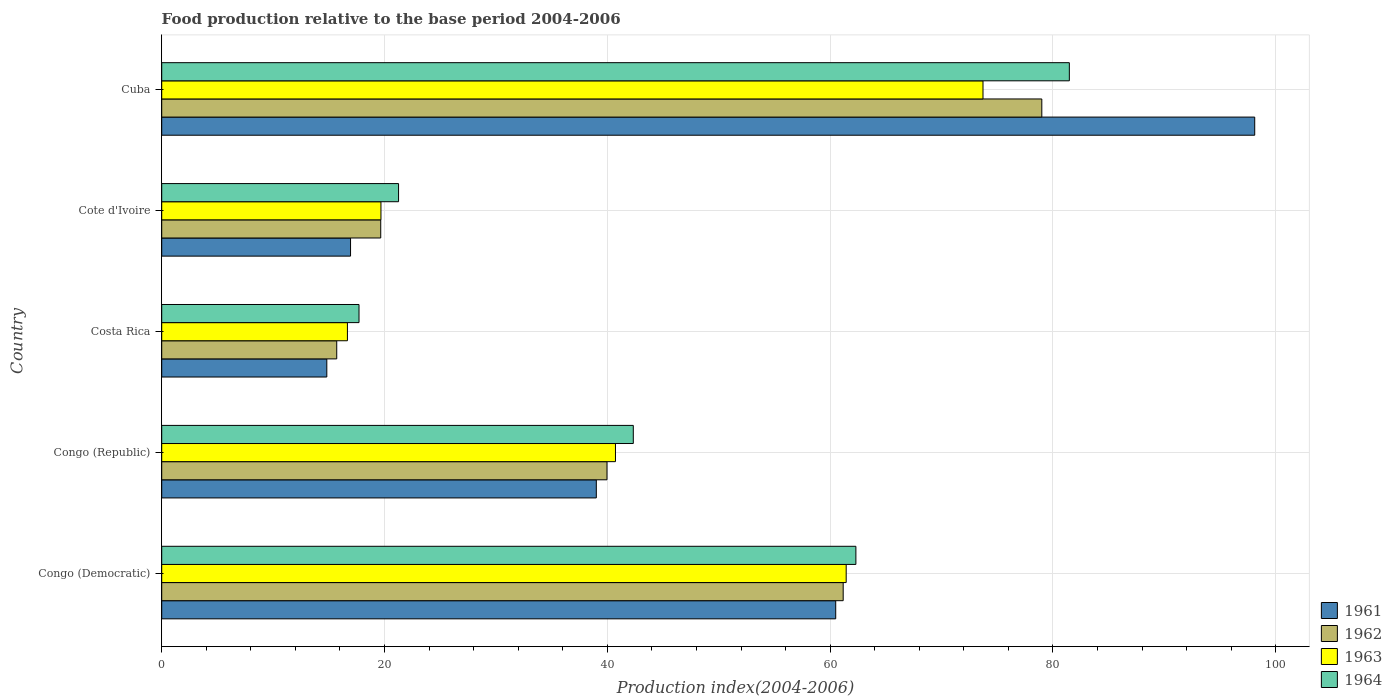How many different coloured bars are there?
Your answer should be compact. 4. Are the number of bars per tick equal to the number of legend labels?
Your answer should be compact. Yes. What is the label of the 2nd group of bars from the top?
Offer a very short reply. Cote d'Ivoire. What is the food production index in 1961 in Cuba?
Your answer should be very brief. 98.11. Across all countries, what is the maximum food production index in 1962?
Give a very brief answer. 79. Across all countries, what is the minimum food production index in 1962?
Offer a terse response. 15.71. In which country was the food production index in 1964 maximum?
Your answer should be very brief. Cuba. What is the total food production index in 1964 in the graph?
Your response must be concise. 225.08. What is the difference between the food production index in 1962 in Costa Rica and that in Cote d'Ivoire?
Offer a terse response. -3.95. What is the difference between the food production index in 1961 in Congo (Democratic) and the food production index in 1962 in Cuba?
Your answer should be very brief. -18.5. What is the average food production index in 1963 per country?
Offer a terse response. 42.45. What is the difference between the food production index in 1964 and food production index in 1961 in Cuba?
Give a very brief answer. -16.64. What is the ratio of the food production index in 1963 in Congo (Democratic) to that in Cuba?
Provide a short and direct response. 0.83. Is the food production index in 1962 in Congo (Democratic) less than that in Costa Rica?
Your answer should be very brief. No. What is the difference between the highest and the second highest food production index in 1961?
Offer a terse response. 37.61. What is the difference between the highest and the lowest food production index in 1962?
Provide a succinct answer. 63.29. In how many countries, is the food production index in 1962 greater than the average food production index in 1962 taken over all countries?
Offer a very short reply. 2. What does the 4th bar from the bottom in Costa Rica represents?
Your answer should be very brief. 1964. How many bars are there?
Your answer should be very brief. 20. How many countries are there in the graph?
Ensure brevity in your answer.  5. Are the values on the major ticks of X-axis written in scientific E-notation?
Offer a very short reply. No. How many legend labels are there?
Your answer should be very brief. 4. What is the title of the graph?
Provide a short and direct response. Food production relative to the base period 2004-2006. What is the label or title of the X-axis?
Offer a terse response. Production index(2004-2006). What is the Production index(2004-2006) of 1961 in Congo (Democratic)?
Provide a succinct answer. 60.5. What is the Production index(2004-2006) in 1962 in Congo (Democratic)?
Your response must be concise. 61.17. What is the Production index(2004-2006) in 1963 in Congo (Democratic)?
Your response must be concise. 61.44. What is the Production index(2004-2006) of 1964 in Congo (Democratic)?
Offer a terse response. 62.31. What is the Production index(2004-2006) of 1961 in Congo (Republic)?
Make the answer very short. 39.01. What is the Production index(2004-2006) of 1962 in Congo (Republic)?
Ensure brevity in your answer.  39.97. What is the Production index(2004-2006) in 1963 in Congo (Republic)?
Make the answer very short. 40.73. What is the Production index(2004-2006) of 1964 in Congo (Republic)?
Offer a terse response. 42.33. What is the Production index(2004-2006) in 1961 in Costa Rica?
Make the answer very short. 14.82. What is the Production index(2004-2006) of 1962 in Costa Rica?
Offer a terse response. 15.71. What is the Production index(2004-2006) in 1963 in Costa Rica?
Your answer should be very brief. 16.67. What is the Production index(2004-2006) in 1964 in Costa Rica?
Your answer should be compact. 17.71. What is the Production index(2004-2006) of 1961 in Cote d'Ivoire?
Offer a terse response. 16.95. What is the Production index(2004-2006) in 1962 in Cote d'Ivoire?
Keep it short and to the point. 19.66. What is the Production index(2004-2006) in 1963 in Cote d'Ivoire?
Offer a terse response. 19.68. What is the Production index(2004-2006) of 1964 in Cote d'Ivoire?
Provide a succinct answer. 21.26. What is the Production index(2004-2006) of 1961 in Cuba?
Provide a succinct answer. 98.11. What is the Production index(2004-2006) of 1962 in Cuba?
Ensure brevity in your answer.  79. What is the Production index(2004-2006) in 1963 in Cuba?
Your answer should be very brief. 73.72. What is the Production index(2004-2006) of 1964 in Cuba?
Provide a succinct answer. 81.47. Across all countries, what is the maximum Production index(2004-2006) in 1961?
Offer a very short reply. 98.11. Across all countries, what is the maximum Production index(2004-2006) of 1962?
Provide a short and direct response. 79. Across all countries, what is the maximum Production index(2004-2006) in 1963?
Your answer should be compact. 73.72. Across all countries, what is the maximum Production index(2004-2006) in 1964?
Offer a terse response. 81.47. Across all countries, what is the minimum Production index(2004-2006) of 1961?
Offer a terse response. 14.82. Across all countries, what is the minimum Production index(2004-2006) of 1962?
Provide a succinct answer. 15.71. Across all countries, what is the minimum Production index(2004-2006) in 1963?
Offer a terse response. 16.67. Across all countries, what is the minimum Production index(2004-2006) of 1964?
Ensure brevity in your answer.  17.71. What is the total Production index(2004-2006) in 1961 in the graph?
Offer a very short reply. 229.39. What is the total Production index(2004-2006) of 1962 in the graph?
Give a very brief answer. 215.51. What is the total Production index(2004-2006) of 1963 in the graph?
Provide a succinct answer. 212.24. What is the total Production index(2004-2006) in 1964 in the graph?
Provide a short and direct response. 225.08. What is the difference between the Production index(2004-2006) in 1961 in Congo (Democratic) and that in Congo (Republic)?
Your answer should be compact. 21.49. What is the difference between the Production index(2004-2006) of 1962 in Congo (Democratic) and that in Congo (Republic)?
Offer a terse response. 21.2. What is the difference between the Production index(2004-2006) in 1963 in Congo (Democratic) and that in Congo (Republic)?
Ensure brevity in your answer.  20.71. What is the difference between the Production index(2004-2006) of 1964 in Congo (Democratic) and that in Congo (Republic)?
Offer a very short reply. 19.98. What is the difference between the Production index(2004-2006) of 1961 in Congo (Democratic) and that in Costa Rica?
Provide a succinct answer. 45.68. What is the difference between the Production index(2004-2006) in 1962 in Congo (Democratic) and that in Costa Rica?
Make the answer very short. 45.46. What is the difference between the Production index(2004-2006) in 1963 in Congo (Democratic) and that in Costa Rica?
Provide a short and direct response. 44.77. What is the difference between the Production index(2004-2006) of 1964 in Congo (Democratic) and that in Costa Rica?
Your answer should be compact. 44.6. What is the difference between the Production index(2004-2006) of 1961 in Congo (Democratic) and that in Cote d'Ivoire?
Give a very brief answer. 43.55. What is the difference between the Production index(2004-2006) in 1962 in Congo (Democratic) and that in Cote d'Ivoire?
Keep it short and to the point. 41.51. What is the difference between the Production index(2004-2006) of 1963 in Congo (Democratic) and that in Cote d'Ivoire?
Provide a succinct answer. 41.76. What is the difference between the Production index(2004-2006) in 1964 in Congo (Democratic) and that in Cote d'Ivoire?
Provide a succinct answer. 41.05. What is the difference between the Production index(2004-2006) in 1961 in Congo (Democratic) and that in Cuba?
Your response must be concise. -37.61. What is the difference between the Production index(2004-2006) of 1962 in Congo (Democratic) and that in Cuba?
Keep it short and to the point. -17.83. What is the difference between the Production index(2004-2006) of 1963 in Congo (Democratic) and that in Cuba?
Make the answer very short. -12.28. What is the difference between the Production index(2004-2006) in 1964 in Congo (Democratic) and that in Cuba?
Provide a succinct answer. -19.16. What is the difference between the Production index(2004-2006) in 1961 in Congo (Republic) and that in Costa Rica?
Your answer should be compact. 24.19. What is the difference between the Production index(2004-2006) of 1962 in Congo (Republic) and that in Costa Rica?
Your answer should be compact. 24.26. What is the difference between the Production index(2004-2006) in 1963 in Congo (Republic) and that in Costa Rica?
Your answer should be compact. 24.06. What is the difference between the Production index(2004-2006) in 1964 in Congo (Republic) and that in Costa Rica?
Ensure brevity in your answer.  24.62. What is the difference between the Production index(2004-2006) in 1961 in Congo (Republic) and that in Cote d'Ivoire?
Ensure brevity in your answer.  22.06. What is the difference between the Production index(2004-2006) in 1962 in Congo (Republic) and that in Cote d'Ivoire?
Provide a succinct answer. 20.31. What is the difference between the Production index(2004-2006) in 1963 in Congo (Republic) and that in Cote d'Ivoire?
Keep it short and to the point. 21.05. What is the difference between the Production index(2004-2006) in 1964 in Congo (Republic) and that in Cote d'Ivoire?
Your response must be concise. 21.07. What is the difference between the Production index(2004-2006) in 1961 in Congo (Republic) and that in Cuba?
Your answer should be very brief. -59.1. What is the difference between the Production index(2004-2006) of 1962 in Congo (Republic) and that in Cuba?
Offer a very short reply. -39.03. What is the difference between the Production index(2004-2006) in 1963 in Congo (Republic) and that in Cuba?
Keep it short and to the point. -32.99. What is the difference between the Production index(2004-2006) in 1964 in Congo (Republic) and that in Cuba?
Offer a terse response. -39.14. What is the difference between the Production index(2004-2006) in 1961 in Costa Rica and that in Cote d'Ivoire?
Make the answer very short. -2.13. What is the difference between the Production index(2004-2006) of 1962 in Costa Rica and that in Cote d'Ivoire?
Offer a terse response. -3.95. What is the difference between the Production index(2004-2006) of 1963 in Costa Rica and that in Cote d'Ivoire?
Give a very brief answer. -3.01. What is the difference between the Production index(2004-2006) of 1964 in Costa Rica and that in Cote d'Ivoire?
Give a very brief answer. -3.55. What is the difference between the Production index(2004-2006) of 1961 in Costa Rica and that in Cuba?
Ensure brevity in your answer.  -83.29. What is the difference between the Production index(2004-2006) in 1962 in Costa Rica and that in Cuba?
Offer a very short reply. -63.29. What is the difference between the Production index(2004-2006) of 1963 in Costa Rica and that in Cuba?
Make the answer very short. -57.05. What is the difference between the Production index(2004-2006) of 1964 in Costa Rica and that in Cuba?
Your answer should be compact. -63.76. What is the difference between the Production index(2004-2006) of 1961 in Cote d'Ivoire and that in Cuba?
Give a very brief answer. -81.16. What is the difference between the Production index(2004-2006) in 1962 in Cote d'Ivoire and that in Cuba?
Provide a succinct answer. -59.34. What is the difference between the Production index(2004-2006) in 1963 in Cote d'Ivoire and that in Cuba?
Keep it short and to the point. -54.04. What is the difference between the Production index(2004-2006) of 1964 in Cote d'Ivoire and that in Cuba?
Offer a very short reply. -60.21. What is the difference between the Production index(2004-2006) of 1961 in Congo (Democratic) and the Production index(2004-2006) of 1962 in Congo (Republic)?
Ensure brevity in your answer.  20.53. What is the difference between the Production index(2004-2006) of 1961 in Congo (Democratic) and the Production index(2004-2006) of 1963 in Congo (Republic)?
Provide a succinct answer. 19.77. What is the difference between the Production index(2004-2006) in 1961 in Congo (Democratic) and the Production index(2004-2006) in 1964 in Congo (Republic)?
Your answer should be compact. 18.17. What is the difference between the Production index(2004-2006) in 1962 in Congo (Democratic) and the Production index(2004-2006) in 1963 in Congo (Republic)?
Your response must be concise. 20.44. What is the difference between the Production index(2004-2006) in 1962 in Congo (Democratic) and the Production index(2004-2006) in 1964 in Congo (Republic)?
Offer a very short reply. 18.84. What is the difference between the Production index(2004-2006) of 1963 in Congo (Democratic) and the Production index(2004-2006) of 1964 in Congo (Republic)?
Make the answer very short. 19.11. What is the difference between the Production index(2004-2006) in 1961 in Congo (Democratic) and the Production index(2004-2006) in 1962 in Costa Rica?
Make the answer very short. 44.79. What is the difference between the Production index(2004-2006) of 1961 in Congo (Democratic) and the Production index(2004-2006) of 1963 in Costa Rica?
Offer a very short reply. 43.83. What is the difference between the Production index(2004-2006) of 1961 in Congo (Democratic) and the Production index(2004-2006) of 1964 in Costa Rica?
Your response must be concise. 42.79. What is the difference between the Production index(2004-2006) in 1962 in Congo (Democratic) and the Production index(2004-2006) in 1963 in Costa Rica?
Provide a succinct answer. 44.5. What is the difference between the Production index(2004-2006) of 1962 in Congo (Democratic) and the Production index(2004-2006) of 1964 in Costa Rica?
Keep it short and to the point. 43.46. What is the difference between the Production index(2004-2006) of 1963 in Congo (Democratic) and the Production index(2004-2006) of 1964 in Costa Rica?
Ensure brevity in your answer.  43.73. What is the difference between the Production index(2004-2006) of 1961 in Congo (Democratic) and the Production index(2004-2006) of 1962 in Cote d'Ivoire?
Offer a very short reply. 40.84. What is the difference between the Production index(2004-2006) in 1961 in Congo (Democratic) and the Production index(2004-2006) in 1963 in Cote d'Ivoire?
Ensure brevity in your answer.  40.82. What is the difference between the Production index(2004-2006) of 1961 in Congo (Democratic) and the Production index(2004-2006) of 1964 in Cote d'Ivoire?
Offer a very short reply. 39.24. What is the difference between the Production index(2004-2006) in 1962 in Congo (Democratic) and the Production index(2004-2006) in 1963 in Cote d'Ivoire?
Offer a terse response. 41.49. What is the difference between the Production index(2004-2006) in 1962 in Congo (Democratic) and the Production index(2004-2006) in 1964 in Cote d'Ivoire?
Offer a terse response. 39.91. What is the difference between the Production index(2004-2006) in 1963 in Congo (Democratic) and the Production index(2004-2006) in 1964 in Cote d'Ivoire?
Keep it short and to the point. 40.18. What is the difference between the Production index(2004-2006) of 1961 in Congo (Democratic) and the Production index(2004-2006) of 1962 in Cuba?
Give a very brief answer. -18.5. What is the difference between the Production index(2004-2006) of 1961 in Congo (Democratic) and the Production index(2004-2006) of 1963 in Cuba?
Keep it short and to the point. -13.22. What is the difference between the Production index(2004-2006) of 1961 in Congo (Democratic) and the Production index(2004-2006) of 1964 in Cuba?
Your answer should be compact. -20.97. What is the difference between the Production index(2004-2006) in 1962 in Congo (Democratic) and the Production index(2004-2006) in 1963 in Cuba?
Your answer should be very brief. -12.55. What is the difference between the Production index(2004-2006) of 1962 in Congo (Democratic) and the Production index(2004-2006) of 1964 in Cuba?
Provide a succinct answer. -20.3. What is the difference between the Production index(2004-2006) in 1963 in Congo (Democratic) and the Production index(2004-2006) in 1964 in Cuba?
Offer a terse response. -20.03. What is the difference between the Production index(2004-2006) of 1961 in Congo (Republic) and the Production index(2004-2006) of 1962 in Costa Rica?
Your answer should be very brief. 23.3. What is the difference between the Production index(2004-2006) of 1961 in Congo (Republic) and the Production index(2004-2006) of 1963 in Costa Rica?
Offer a very short reply. 22.34. What is the difference between the Production index(2004-2006) in 1961 in Congo (Republic) and the Production index(2004-2006) in 1964 in Costa Rica?
Offer a very short reply. 21.3. What is the difference between the Production index(2004-2006) in 1962 in Congo (Republic) and the Production index(2004-2006) in 1963 in Costa Rica?
Provide a short and direct response. 23.3. What is the difference between the Production index(2004-2006) in 1962 in Congo (Republic) and the Production index(2004-2006) in 1964 in Costa Rica?
Offer a very short reply. 22.26. What is the difference between the Production index(2004-2006) of 1963 in Congo (Republic) and the Production index(2004-2006) of 1964 in Costa Rica?
Offer a terse response. 23.02. What is the difference between the Production index(2004-2006) of 1961 in Congo (Republic) and the Production index(2004-2006) of 1962 in Cote d'Ivoire?
Offer a terse response. 19.35. What is the difference between the Production index(2004-2006) of 1961 in Congo (Republic) and the Production index(2004-2006) of 1963 in Cote d'Ivoire?
Your response must be concise. 19.33. What is the difference between the Production index(2004-2006) of 1961 in Congo (Republic) and the Production index(2004-2006) of 1964 in Cote d'Ivoire?
Your response must be concise. 17.75. What is the difference between the Production index(2004-2006) in 1962 in Congo (Republic) and the Production index(2004-2006) in 1963 in Cote d'Ivoire?
Offer a very short reply. 20.29. What is the difference between the Production index(2004-2006) in 1962 in Congo (Republic) and the Production index(2004-2006) in 1964 in Cote d'Ivoire?
Your answer should be compact. 18.71. What is the difference between the Production index(2004-2006) in 1963 in Congo (Republic) and the Production index(2004-2006) in 1964 in Cote d'Ivoire?
Your response must be concise. 19.47. What is the difference between the Production index(2004-2006) in 1961 in Congo (Republic) and the Production index(2004-2006) in 1962 in Cuba?
Give a very brief answer. -39.99. What is the difference between the Production index(2004-2006) of 1961 in Congo (Republic) and the Production index(2004-2006) of 1963 in Cuba?
Your response must be concise. -34.71. What is the difference between the Production index(2004-2006) of 1961 in Congo (Republic) and the Production index(2004-2006) of 1964 in Cuba?
Your answer should be compact. -42.46. What is the difference between the Production index(2004-2006) of 1962 in Congo (Republic) and the Production index(2004-2006) of 1963 in Cuba?
Offer a terse response. -33.75. What is the difference between the Production index(2004-2006) of 1962 in Congo (Republic) and the Production index(2004-2006) of 1964 in Cuba?
Make the answer very short. -41.5. What is the difference between the Production index(2004-2006) in 1963 in Congo (Republic) and the Production index(2004-2006) in 1964 in Cuba?
Provide a succinct answer. -40.74. What is the difference between the Production index(2004-2006) in 1961 in Costa Rica and the Production index(2004-2006) in 1962 in Cote d'Ivoire?
Your answer should be compact. -4.84. What is the difference between the Production index(2004-2006) in 1961 in Costa Rica and the Production index(2004-2006) in 1963 in Cote d'Ivoire?
Ensure brevity in your answer.  -4.86. What is the difference between the Production index(2004-2006) in 1961 in Costa Rica and the Production index(2004-2006) in 1964 in Cote d'Ivoire?
Your answer should be very brief. -6.44. What is the difference between the Production index(2004-2006) of 1962 in Costa Rica and the Production index(2004-2006) of 1963 in Cote d'Ivoire?
Offer a terse response. -3.97. What is the difference between the Production index(2004-2006) in 1962 in Costa Rica and the Production index(2004-2006) in 1964 in Cote d'Ivoire?
Offer a very short reply. -5.55. What is the difference between the Production index(2004-2006) in 1963 in Costa Rica and the Production index(2004-2006) in 1964 in Cote d'Ivoire?
Your response must be concise. -4.59. What is the difference between the Production index(2004-2006) of 1961 in Costa Rica and the Production index(2004-2006) of 1962 in Cuba?
Provide a short and direct response. -64.18. What is the difference between the Production index(2004-2006) of 1961 in Costa Rica and the Production index(2004-2006) of 1963 in Cuba?
Offer a very short reply. -58.9. What is the difference between the Production index(2004-2006) of 1961 in Costa Rica and the Production index(2004-2006) of 1964 in Cuba?
Give a very brief answer. -66.65. What is the difference between the Production index(2004-2006) of 1962 in Costa Rica and the Production index(2004-2006) of 1963 in Cuba?
Provide a short and direct response. -58.01. What is the difference between the Production index(2004-2006) of 1962 in Costa Rica and the Production index(2004-2006) of 1964 in Cuba?
Give a very brief answer. -65.76. What is the difference between the Production index(2004-2006) of 1963 in Costa Rica and the Production index(2004-2006) of 1964 in Cuba?
Keep it short and to the point. -64.8. What is the difference between the Production index(2004-2006) in 1961 in Cote d'Ivoire and the Production index(2004-2006) in 1962 in Cuba?
Provide a short and direct response. -62.05. What is the difference between the Production index(2004-2006) of 1961 in Cote d'Ivoire and the Production index(2004-2006) of 1963 in Cuba?
Provide a short and direct response. -56.77. What is the difference between the Production index(2004-2006) of 1961 in Cote d'Ivoire and the Production index(2004-2006) of 1964 in Cuba?
Make the answer very short. -64.52. What is the difference between the Production index(2004-2006) in 1962 in Cote d'Ivoire and the Production index(2004-2006) in 1963 in Cuba?
Your answer should be very brief. -54.06. What is the difference between the Production index(2004-2006) in 1962 in Cote d'Ivoire and the Production index(2004-2006) in 1964 in Cuba?
Provide a succinct answer. -61.81. What is the difference between the Production index(2004-2006) of 1963 in Cote d'Ivoire and the Production index(2004-2006) of 1964 in Cuba?
Give a very brief answer. -61.79. What is the average Production index(2004-2006) of 1961 per country?
Your answer should be very brief. 45.88. What is the average Production index(2004-2006) of 1962 per country?
Provide a succinct answer. 43.1. What is the average Production index(2004-2006) in 1963 per country?
Your response must be concise. 42.45. What is the average Production index(2004-2006) of 1964 per country?
Your answer should be compact. 45.02. What is the difference between the Production index(2004-2006) in 1961 and Production index(2004-2006) in 1962 in Congo (Democratic)?
Give a very brief answer. -0.67. What is the difference between the Production index(2004-2006) of 1961 and Production index(2004-2006) of 1963 in Congo (Democratic)?
Provide a succinct answer. -0.94. What is the difference between the Production index(2004-2006) in 1961 and Production index(2004-2006) in 1964 in Congo (Democratic)?
Keep it short and to the point. -1.81. What is the difference between the Production index(2004-2006) of 1962 and Production index(2004-2006) of 1963 in Congo (Democratic)?
Ensure brevity in your answer.  -0.27. What is the difference between the Production index(2004-2006) in 1962 and Production index(2004-2006) in 1964 in Congo (Democratic)?
Offer a terse response. -1.14. What is the difference between the Production index(2004-2006) of 1963 and Production index(2004-2006) of 1964 in Congo (Democratic)?
Your response must be concise. -0.87. What is the difference between the Production index(2004-2006) of 1961 and Production index(2004-2006) of 1962 in Congo (Republic)?
Offer a terse response. -0.96. What is the difference between the Production index(2004-2006) in 1961 and Production index(2004-2006) in 1963 in Congo (Republic)?
Provide a succinct answer. -1.72. What is the difference between the Production index(2004-2006) of 1961 and Production index(2004-2006) of 1964 in Congo (Republic)?
Provide a short and direct response. -3.32. What is the difference between the Production index(2004-2006) of 1962 and Production index(2004-2006) of 1963 in Congo (Republic)?
Your answer should be very brief. -0.76. What is the difference between the Production index(2004-2006) in 1962 and Production index(2004-2006) in 1964 in Congo (Republic)?
Your answer should be very brief. -2.36. What is the difference between the Production index(2004-2006) in 1963 and Production index(2004-2006) in 1964 in Congo (Republic)?
Your response must be concise. -1.6. What is the difference between the Production index(2004-2006) of 1961 and Production index(2004-2006) of 1962 in Costa Rica?
Ensure brevity in your answer.  -0.89. What is the difference between the Production index(2004-2006) of 1961 and Production index(2004-2006) of 1963 in Costa Rica?
Provide a short and direct response. -1.85. What is the difference between the Production index(2004-2006) of 1961 and Production index(2004-2006) of 1964 in Costa Rica?
Provide a short and direct response. -2.89. What is the difference between the Production index(2004-2006) of 1962 and Production index(2004-2006) of 1963 in Costa Rica?
Keep it short and to the point. -0.96. What is the difference between the Production index(2004-2006) in 1963 and Production index(2004-2006) in 1964 in Costa Rica?
Make the answer very short. -1.04. What is the difference between the Production index(2004-2006) of 1961 and Production index(2004-2006) of 1962 in Cote d'Ivoire?
Make the answer very short. -2.71. What is the difference between the Production index(2004-2006) in 1961 and Production index(2004-2006) in 1963 in Cote d'Ivoire?
Provide a succinct answer. -2.73. What is the difference between the Production index(2004-2006) in 1961 and Production index(2004-2006) in 1964 in Cote d'Ivoire?
Keep it short and to the point. -4.31. What is the difference between the Production index(2004-2006) of 1962 and Production index(2004-2006) of 1963 in Cote d'Ivoire?
Your answer should be very brief. -0.02. What is the difference between the Production index(2004-2006) in 1962 and Production index(2004-2006) in 1964 in Cote d'Ivoire?
Your answer should be very brief. -1.6. What is the difference between the Production index(2004-2006) of 1963 and Production index(2004-2006) of 1964 in Cote d'Ivoire?
Provide a succinct answer. -1.58. What is the difference between the Production index(2004-2006) in 1961 and Production index(2004-2006) in 1962 in Cuba?
Offer a terse response. 19.11. What is the difference between the Production index(2004-2006) of 1961 and Production index(2004-2006) of 1963 in Cuba?
Your answer should be very brief. 24.39. What is the difference between the Production index(2004-2006) in 1961 and Production index(2004-2006) in 1964 in Cuba?
Provide a succinct answer. 16.64. What is the difference between the Production index(2004-2006) in 1962 and Production index(2004-2006) in 1963 in Cuba?
Give a very brief answer. 5.28. What is the difference between the Production index(2004-2006) in 1962 and Production index(2004-2006) in 1964 in Cuba?
Ensure brevity in your answer.  -2.47. What is the difference between the Production index(2004-2006) in 1963 and Production index(2004-2006) in 1964 in Cuba?
Provide a short and direct response. -7.75. What is the ratio of the Production index(2004-2006) of 1961 in Congo (Democratic) to that in Congo (Republic)?
Your response must be concise. 1.55. What is the ratio of the Production index(2004-2006) in 1962 in Congo (Democratic) to that in Congo (Republic)?
Your answer should be compact. 1.53. What is the ratio of the Production index(2004-2006) in 1963 in Congo (Democratic) to that in Congo (Republic)?
Your answer should be very brief. 1.51. What is the ratio of the Production index(2004-2006) of 1964 in Congo (Democratic) to that in Congo (Republic)?
Ensure brevity in your answer.  1.47. What is the ratio of the Production index(2004-2006) of 1961 in Congo (Democratic) to that in Costa Rica?
Provide a succinct answer. 4.08. What is the ratio of the Production index(2004-2006) of 1962 in Congo (Democratic) to that in Costa Rica?
Make the answer very short. 3.89. What is the ratio of the Production index(2004-2006) in 1963 in Congo (Democratic) to that in Costa Rica?
Offer a very short reply. 3.69. What is the ratio of the Production index(2004-2006) of 1964 in Congo (Democratic) to that in Costa Rica?
Your response must be concise. 3.52. What is the ratio of the Production index(2004-2006) of 1961 in Congo (Democratic) to that in Cote d'Ivoire?
Offer a very short reply. 3.57. What is the ratio of the Production index(2004-2006) in 1962 in Congo (Democratic) to that in Cote d'Ivoire?
Ensure brevity in your answer.  3.11. What is the ratio of the Production index(2004-2006) in 1963 in Congo (Democratic) to that in Cote d'Ivoire?
Ensure brevity in your answer.  3.12. What is the ratio of the Production index(2004-2006) of 1964 in Congo (Democratic) to that in Cote d'Ivoire?
Offer a terse response. 2.93. What is the ratio of the Production index(2004-2006) of 1961 in Congo (Democratic) to that in Cuba?
Provide a short and direct response. 0.62. What is the ratio of the Production index(2004-2006) in 1962 in Congo (Democratic) to that in Cuba?
Provide a short and direct response. 0.77. What is the ratio of the Production index(2004-2006) of 1963 in Congo (Democratic) to that in Cuba?
Offer a terse response. 0.83. What is the ratio of the Production index(2004-2006) in 1964 in Congo (Democratic) to that in Cuba?
Your answer should be very brief. 0.76. What is the ratio of the Production index(2004-2006) of 1961 in Congo (Republic) to that in Costa Rica?
Your answer should be very brief. 2.63. What is the ratio of the Production index(2004-2006) in 1962 in Congo (Republic) to that in Costa Rica?
Your answer should be compact. 2.54. What is the ratio of the Production index(2004-2006) of 1963 in Congo (Republic) to that in Costa Rica?
Provide a short and direct response. 2.44. What is the ratio of the Production index(2004-2006) in 1964 in Congo (Republic) to that in Costa Rica?
Your answer should be very brief. 2.39. What is the ratio of the Production index(2004-2006) in 1961 in Congo (Republic) to that in Cote d'Ivoire?
Ensure brevity in your answer.  2.3. What is the ratio of the Production index(2004-2006) in 1962 in Congo (Republic) to that in Cote d'Ivoire?
Your answer should be compact. 2.03. What is the ratio of the Production index(2004-2006) of 1963 in Congo (Republic) to that in Cote d'Ivoire?
Keep it short and to the point. 2.07. What is the ratio of the Production index(2004-2006) in 1964 in Congo (Republic) to that in Cote d'Ivoire?
Your response must be concise. 1.99. What is the ratio of the Production index(2004-2006) of 1961 in Congo (Republic) to that in Cuba?
Your answer should be compact. 0.4. What is the ratio of the Production index(2004-2006) of 1962 in Congo (Republic) to that in Cuba?
Your answer should be very brief. 0.51. What is the ratio of the Production index(2004-2006) in 1963 in Congo (Republic) to that in Cuba?
Provide a short and direct response. 0.55. What is the ratio of the Production index(2004-2006) in 1964 in Congo (Republic) to that in Cuba?
Provide a succinct answer. 0.52. What is the ratio of the Production index(2004-2006) of 1961 in Costa Rica to that in Cote d'Ivoire?
Keep it short and to the point. 0.87. What is the ratio of the Production index(2004-2006) of 1962 in Costa Rica to that in Cote d'Ivoire?
Provide a short and direct response. 0.8. What is the ratio of the Production index(2004-2006) of 1963 in Costa Rica to that in Cote d'Ivoire?
Ensure brevity in your answer.  0.85. What is the ratio of the Production index(2004-2006) of 1964 in Costa Rica to that in Cote d'Ivoire?
Give a very brief answer. 0.83. What is the ratio of the Production index(2004-2006) in 1961 in Costa Rica to that in Cuba?
Ensure brevity in your answer.  0.15. What is the ratio of the Production index(2004-2006) in 1962 in Costa Rica to that in Cuba?
Ensure brevity in your answer.  0.2. What is the ratio of the Production index(2004-2006) of 1963 in Costa Rica to that in Cuba?
Make the answer very short. 0.23. What is the ratio of the Production index(2004-2006) of 1964 in Costa Rica to that in Cuba?
Your answer should be compact. 0.22. What is the ratio of the Production index(2004-2006) in 1961 in Cote d'Ivoire to that in Cuba?
Provide a succinct answer. 0.17. What is the ratio of the Production index(2004-2006) in 1962 in Cote d'Ivoire to that in Cuba?
Provide a succinct answer. 0.25. What is the ratio of the Production index(2004-2006) in 1963 in Cote d'Ivoire to that in Cuba?
Provide a succinct answer. 0.27. What is the ratio of the Production index(2004-2006) in 1964 in Cote d'Ivoire to that in Cuba?
Make the answer very short. 0.26. What is the difference between the highest and the second highest Production index(2004-2006) in 1961?
Provide a short and direct response. 37.61. What is the difference between the highest and the second highest Production index(2004-2006) in 1962?
Your response must be concise. 17.83. What is the difference between the highest and the second highest Production index(2004-2006) of 1963?
Your answer should be compact. 12.28. What is the difference between the highest and the second highest Production index(2004-2006) of 1964?
Your answer should be very brief. 19.16. What is the difference between the highest and the lowest Production index(2004-2006) of 1961?
Provide a succinct answer. 83.29. What is the difference between the highest and the lowest Production index(2004-2006) in 1962?
Your answer should be very brief. 63.29. What is the difference between the highest and the lowest Production index(2004-2006) in 1963?
Your answer should be compact. 57.05. What is the difference between the highest and the lowest Production index(2004-2006) of 1964?
Offer a very short reply. 63.76. 